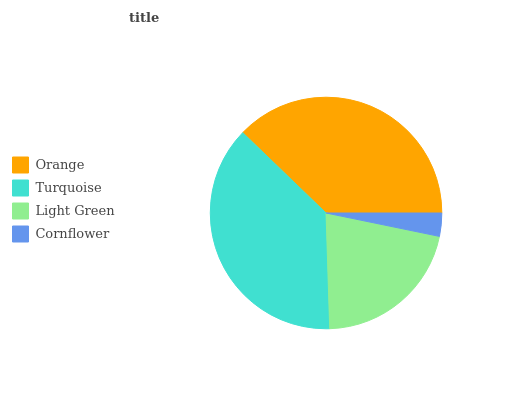Is Cornflower the minimum?
Answer yes or no. Yes. Is Orange the maximum?
Answer yes or no. Yes. Is Turquoise the minimum?
Answer yes or no. No. Is Turquoise the maximum?
Answer yes or no. No. Is Orange greater than Turquoise?
Answer yes or no. Yes. Is Turquoise less than Orange?
Answer yes or no. Yes. Is Turquoise greater than Orange?
Answer yes or no. No. Is Orange less than Turquoise?
Answer yes or no. No. Is Turquoise the high median?
Answer yes or no. Yes. Is Light Green the low median?
Answer yes or no. Yes. Is Orange the high median?
Answer yes or no. No. Is Cornflower the low median?
Answer yes or no. No. 